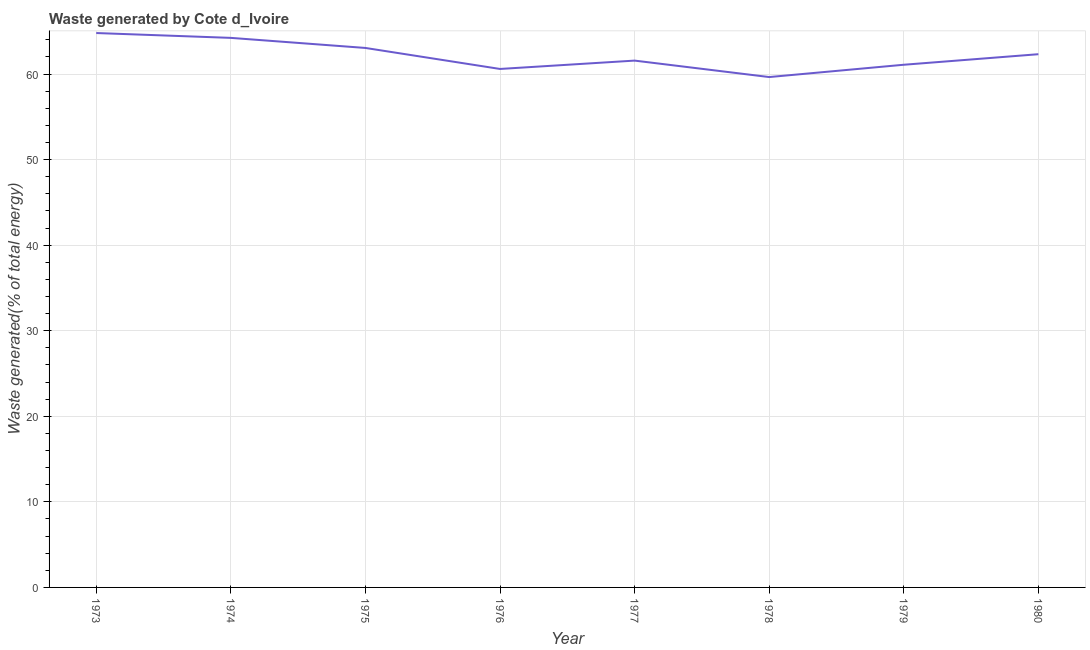What is the amount of waste generated in 1976?
Your answer should be compact. 60.6. Across all years, what is the maximum amount of waste generated?
Offer a terse response. 64.8. Across all years, what is the minimum amount of waste generated?
Offer a very short reply. 59.65. In which year was the amount of waste generated minimum?
Give a very brief answer. 1978. What is the sum of the amount of waste generated?
Your answer should be very brief. 497.3. What is the difference between the amount of waste generated in 1976 and 1977?
Ensure brevity in your answer.  -0.98. What is the average amount of waste generated per year?
Keep it short and to the point. 62.16. What is the median amount of waste generated?
Offer a very short reply. 61.95. In how many years, is the amount of waste generated greater than 26 %?
Provide a short and direct response. 8. What is the ratio of the amount of waste generated in 1974 to that in 1980?
Provide a short and direct response. 1.03. Is the difference between the amount of waste generated in 1974 and 1975 greater than the difference between any two years?
Make the answer very short. No. What is the difference between the highest and the second highest amount of waste generated?
Your answer should be compact. 0.57. What is the difference between the highest and the lowest amount of waste generated?
Your answer should be very brief. 5.15. In how many years, is the amount of waste generated greater than the average amount of waste generated taken over all years?
Your response must be concise. 4. Does the amount of waste generated monotonically increase over the years?
Ensure brevity in your answer.  No. How many lines are there?
Offer a very short reply. 1. How many years are there in the graph?
Your response must be concise. 8. What is the difference between two consecutive major ticks on the Y-axis?
Give a very brief answer. 10. Are the values on the major ticks of Y-axis written in scientific E-notation?
Offer a terse response. No. Does the graph contain grids?
Provide a succinct answer. Yes. What is the title of the graph?
Make the answer very short. Waste generated by Cote d_Ivoire. What is the label or title of the X-axis?
Provide a succinct answer. Year. What is the label or title of the Y-axis?
Your answer should be very brief. Waste generated(% of total energy). What is the Waste generated(% of total energy) in 1973?
Offer a very short reply. 64.8. What is the Waste generated(% of total energy) of 1974?
Your answer should be very brief. 64.23. What is the Waste generated(% of total energy) in 1975?
Offer a very short reply. 63.05. What is the Waste generated(% of total energy) of 1976?
Offer a very short reply. 60.6. What is the Waste generated(% of total energy) of 1977?
Provide a short and direct response. 61.57. What is the Waste generated(% of total energy) in 1978?
Ensure brevity in your answer.  59.65. What is the Waste generated(% of total energy) in 1979?
Your response must be concise. 61.09. What is the Waste generated(% of total energy) in 1980?
Keep it short and to the point. 62.32. What is the difference between the Waste generated(% of total energy) in 1973 and 1974?
Keep it short and to the point. 0.57. What is the difference between the Waste generated(% of total energy) in 1973 and 1975?
Offer a very short reply. 1.74. What is the difference between the Waste generated(% of total energy) in 1973 and 1976?
Your answer should be very brief. 4.2. What is the difference between the Waste generated(% of total energy) in 1973 and 1977?
Provide a succinct answer. 3.22. What is the difference between the Waste generated(% of total energy) in 1973 and 1978?
Give a very brief answer. 5.15. What is the difference between the Waste generated(% of total energy) in 1973 and 1979?
Your answer should be very brief. 3.71. What is the difference between the Waste generated(% of total energy) in 1973 and 1980?
Ensure brevity in your answer.  2.47. What is the difference between the Waste generated(% of total energy) in 1974 and 1975?
Your answer should be very brief. 1.18. What is the difference between the Waste generated(% of total energy) in 1974 and 1976?
Your response must be concise. 3.63. What is the difference between the Waste generated(% of total energy) in 1974 and 1977?
Give a very brief answer. 2.66. What is the difference between the Waste generated(% of total energy) in 1974 and 1978?
Offer a very short reply. 4.58. What is the difference between the Waste generated(% of total energy) in 1974 and 1979?
Your answer should be very brief. 3.14. What is the difference between the Waste generated(% of total energy) in 1974 and 1980?
Give a very brief answer. 1.91. What is the difference between the Waste generated(% of total energy) in 1975 and 1976?
Provide a short and direct response. 2.45. What is the difference between the Waste generated(% of total energy) in 1975 and 1977?
Offer a terse response. 1.48. What is the difference between the Waste generated(% of total energy) in 1975 and 1978?
Keep it short and to the point. 3.4. What is the difference between the Waste generated(% of total energy) in 1975 and 1979?
Keep it short and to the point. 1.96. What is the difference between the Waste generated(% of total energy) in 1975 and 1980?
Provide a short and direct response. 0.73. What is the difference between the Waste generated(% of total energy) in 1976 and 1977?
Offer a terse response. -0.98. What is the difference between the Waste generated(% of total energy) in 1976 and 1978?
Give a very brief answer. 0.95. What is the difference between the Waste generated(% of total energy) in 1976 and 1979?
Ensure brevity in your answer.  -0.49. What is the difference between the Waste generated(% of total energy) in 1976 and 1980?
Make the answer very short. -1.72. What is the difference between the Waste generated(% of total energy) in 1977 and 1978?
Give a very brief answer. 1.92. What is the difference between the Waste generated(% of total energy) in 1977 and 1979?
Keep it short and to the point. 0.48. What is the difference between the Waste generated(% of total energy) in 1977 and 1980?
Your response must be concise. -0.75. What is the difference between the Waste generated(% of total energy) in 1978 and 1979?
Make the answer very short. -1.44. What is the difference between the Waste generated(% of total energy) in 1978 and 1980?
Provide a short and direct response. -2.67. What is the difference between the Waste generated(% of total energy) in 1979 and 1980?
Your answer should be compact. -1.23. What is the ratio of the Waste generated(% of total energy) in 1973 to that in 1975?
Your answer should be very brief. 1.03. What is the ratio of the Waste generated(% of total energy) in 1973 to that in 1976?
Offer a terse response. 1.07. What is the ratio of the Waste generated(% of total energy) in 1973 to that in 1977?
Provide a succinct answer. 1.05. What is the ratio of the Waste generated(% of total energy) in 1973 to that in 1978?
Give a very brief answer. 1.09. What is the ratio of the Waste generated(% of total energy) in 1973 to that in 1979?
Make the answer very short. 1.06. What is the ratio of the Waste generated(% of total energy) in 1974 to that in 1975?
Provide a short and direct response. 1.02. What is the ratio of the Waste generated(% of total energy) in 1974 to that in 1976?
Offer a very short reply. 1.06. What is the ratio of the Waste generated(% of total energy) in 1974 to that in 1977?
Your answer should be very brief. 1.04. What is the ratio of the Waste generated(% of total energy) in 1974 to that in 1978?
Give a very brief answer. 1.08. What is the ratio of the Waste generated(% of total energy) in 1974 to that in 1979?
Your answer should be compact. 1.05. What is the ratio of the Waste generated(% of total energy) in 1974 to that in 1980?
Provide a short and direct response. 1.03. What is the ratio of the Waste generated(% of total energy) in 1975 to that in 1976?
Offer a terse response. 1.04. What is the ratio of the Waste generated(% of total energy) in 1975 to that in 1977?
Your answer should be compact. 1.02. What is the ratio of the Waste generated(% of total energy) in 1975 to that in 1978?
Your answer should be compact. 1.06. What is the ratio of the Waste generated(% of total energy) in 1975 to that in 1979?
Your answer should be very brief. 1.03. What is the ratio of the Waste generated(% of total energy) in 1976 to that in 1979?
Ensure brevity in your answer.  0.99. What is the ratio of the Waste generated(% of total energy) in 1976 to that in 1980?
Offer a terse response. 0.97. What is the ratio of the Waste generated(% of total energy) in 1977 to that in 1978?
Offer a terse response. 1.03. What is the ratio of the Waste generated(% of total energy) in 1977 to that in 1979?
Give a very brief answer. 1.01. 